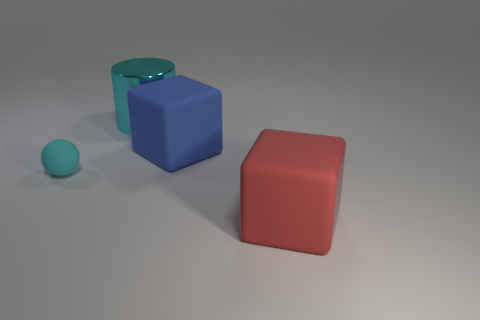Subtract 1 cubes. How many cubes are left? 1 Add 3 small green things. How many objects exist? 7 Subtract all red cubes. How many cubes are left? 1 Subtract all red cylinders. How many red cubes are left? 1 Add 3 large shiny cylinders. How many large shiny cylinders exist? 4 Subtract 0 brown spheres. How many objects are left? 4 Subtract all cylinders. How many objects are left? 3 Subtract all brown balls. Subtract all cyan cubes. How many balls are left? 1 Subtract all cyan cylinders. Subtract all cyan metallic cylinders. How many objects are left? 2 Add 3 cyan objects. How many cyan objects are left? 5 